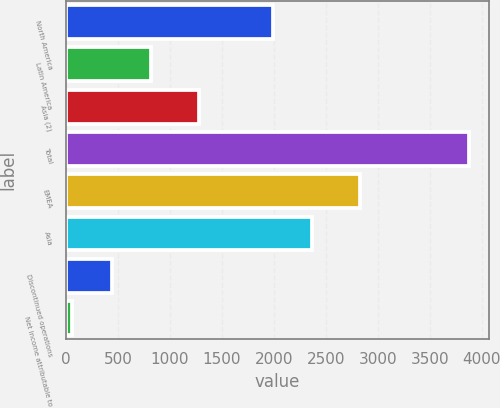Convert chart. <chart><loc_0><loc_0><loc_500><loc_500><bar_chart><fcel>North America<fcel>Latin America<fcel>Asia (2)<fcel>Total<fcel>EMEA<fcel>Asia<fcel>Discontinued operations<fcel>Net income attributable to<nl><fcel>1990<fcel>823.6<fcel>1278<fcel>3878<fcel>2832<fcel>2371.8<fcel>441.8<fcel>60<nl></chart> 